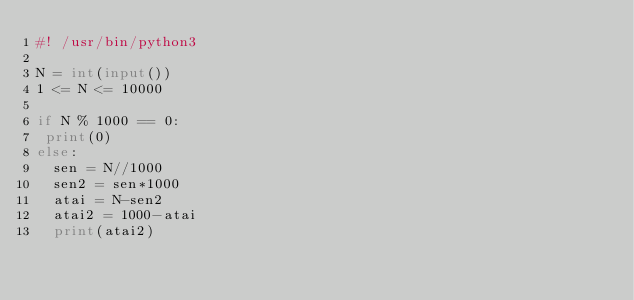<code> <loc_0><loc_0><loc_500><loc_500><_Python_>#! /usr/bin/python3

N = int(input())
1 <= N <= 10000

if N % 1000 == 0:
 print(0)
else:
  sen = N//1000
  sen2 = sen*1000
  atai = N-sen2
  atai2 = 1000-atai
  print(atai2)</code> 